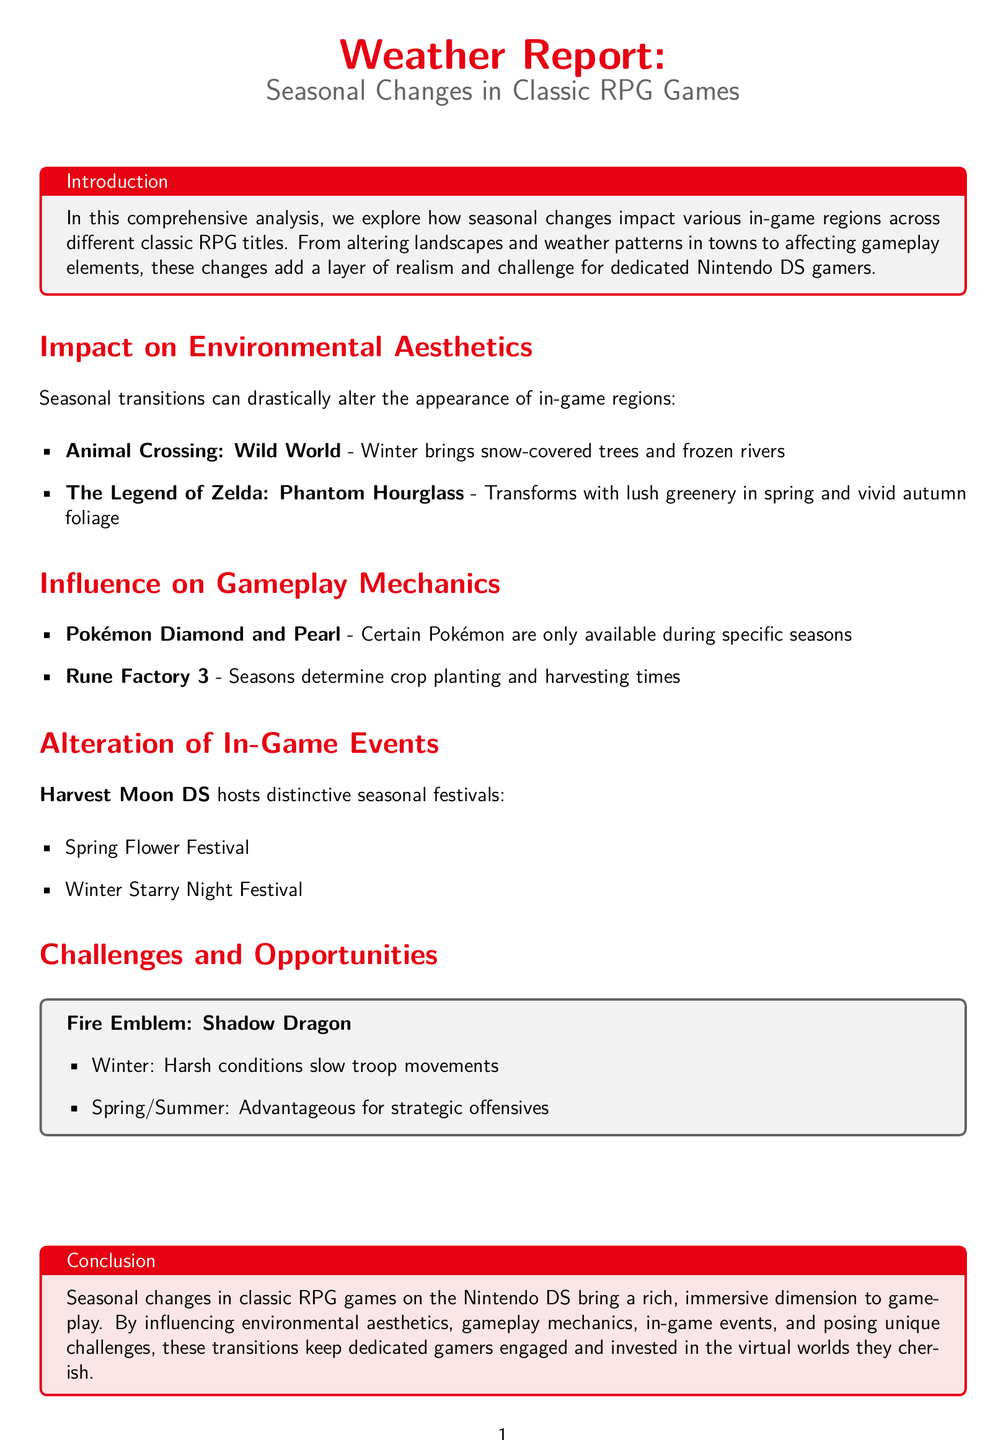What RPG game features snow-covered trees in winter? The document mentions that "Animal Crossing: Wild World" features snow-covered trees in winter.
Answer: Animal Crossing: Wild World Which season affects crop planting and harvesting in Rune Factory 3? The document states that in "Rune Factory 3," seasons determine crop planting and harvesting times, indicating that all seasons affect it.
Answer: All seasons How do winter conditions affect troop movements in Fire Emblem: Shadow Dragon? The document indicates that in "Fire Emblem: Shadow Dragon," harsh conditions in winter slow troop movements.
Answer: Slow troop movements What festival occurs during spring in Harvest Moon DS? The document lists the "Spring Flower Festival" as an event in "Harvest Moon DS."
Answer: Spring Flower Festival What is the impact of seasonal changes on environmental aesthetics in classic RPGs? The document mentions that seasonal transitions can drastically alter the appearance of in-game regions, showing an influence on aesthetics.
Answer: Drastically alter Which game is associated with autumn foliage in the document? The document indicates that "The Legend of Zelda: Phantom Hourglass" transforms with vivid autumn foliage.
Answer: The Legend of Zelda: Phantom Hourglass What does the document conclude about seasonal changes in RPG games? The conclusion summarizes that seasonal changes in classic RPG games bring a rich, immersive dimension to gameplay.
Answer: Rich, immersive dimension Which season offers an advantage for strategic offensives in Fire Emblem: Shadow Dragon? The document states that spring and summer are advantageous for strategic offensives in "Fire Emblem: Shadow Dragon."
Answer: Spring/Summer 